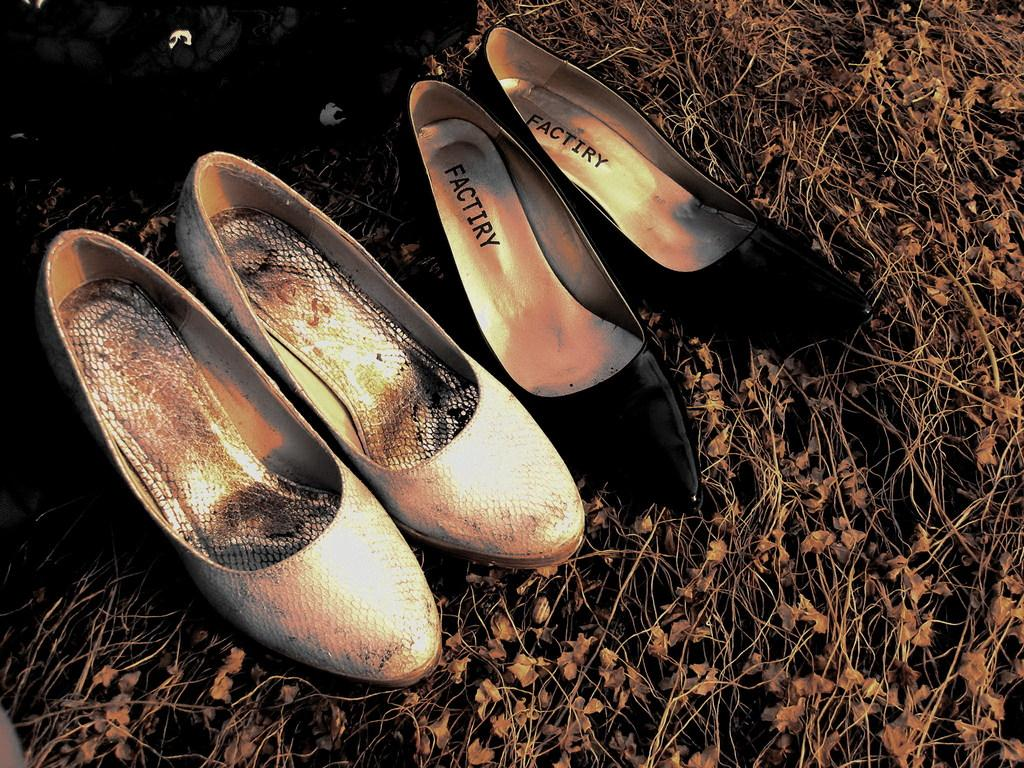How many pairs of ballerina shoes are in the image? There are two pairs of ballerina shoes in the image. What is the name of the person who owns the ballerina shoes in the image? The provided facts do not mention any names or individuals, so it is impossible to determine the owner of the ballerina shoes in the image. 